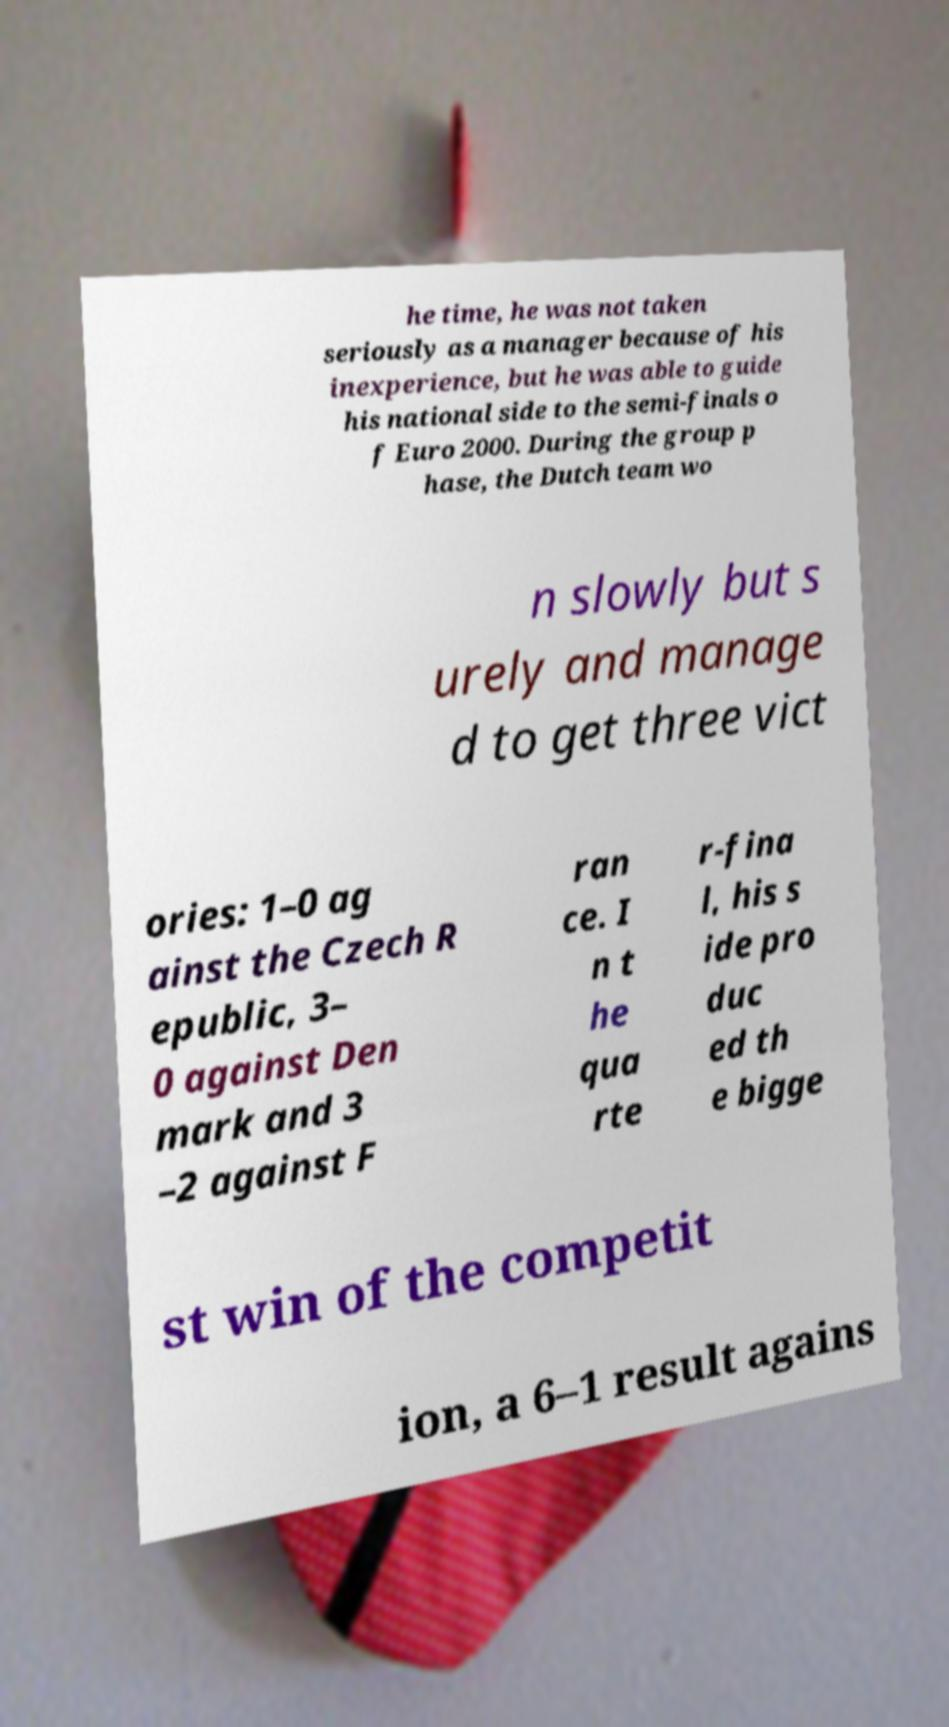For documentation purposes, I need the text within this image transcribed. Could you provide that? he time, he was not taken seriously as a manager because of his inexperience, but he was able to guide his national side to the semi-finals o f Euro 2000. During the group p hase, the Dutch team wo n slowly but s urely and manage d to get three vict ories: 1–0 ag ainst the Czech R epublic, 3– 0 against Den mark and 3 –2 against F ran ce. I n t he qua rte r-fina l, his s ide pro duc ed th e bigge st win of the competit ion, a 6–1 result agains 